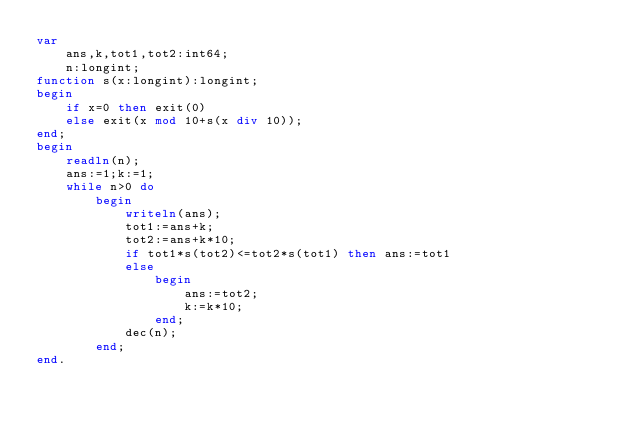Convert code to text. <code><loc_0><loc_0><loc_500><loc_500><_Pascal_>var
    ans,k,tot1,tot2:int64;
    n:longint;
function s(x:longint):longint;
begin
    if x=0 then exit(0)
    else exit(x mod 10+s(x div 10));
end;
begin
    readln(n);
    ans:=1;k:=1;
    while n>0 do
        begin
            writeln(ans);
            tot1:=ans+k;
            tot2:=ans+k*10;
            if tot1*s(tot2)<=tot2*s(tot1) then ans:=tot1
            else
                begin
                    ans:=tot2;
                    k:=k*10;
                end;
            dec(n);
        end;
end.</code> 